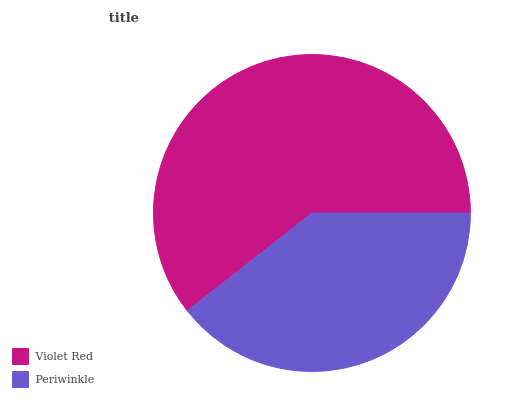Is Periwinkle the minimum?
Answer yes or no. Yes. Is Violet Red the maximum?
Answer yes or no. Yes. Is Periwinkle the maximum?
Answer yes or no. No. Is Violet Red greater than Periwinkle?
Answer yes or no. Yes. Is Periwinkle less than Violet Red?
Answer yes or no. Yes. Is Periwinkle greater than Violet Red?
Answer yes or no. No. Is Violet Red less than Periwinkle?
Answer yes or no. No. Is Violet Red the high median?
Answer yes or no. Yes. Is Periwinkle the low median?
Answer yes or no. Yes. Is Periwinkle the high median?
Answer yes or no. No. Is Violet Red the low median?
Answer yes or no. No. 